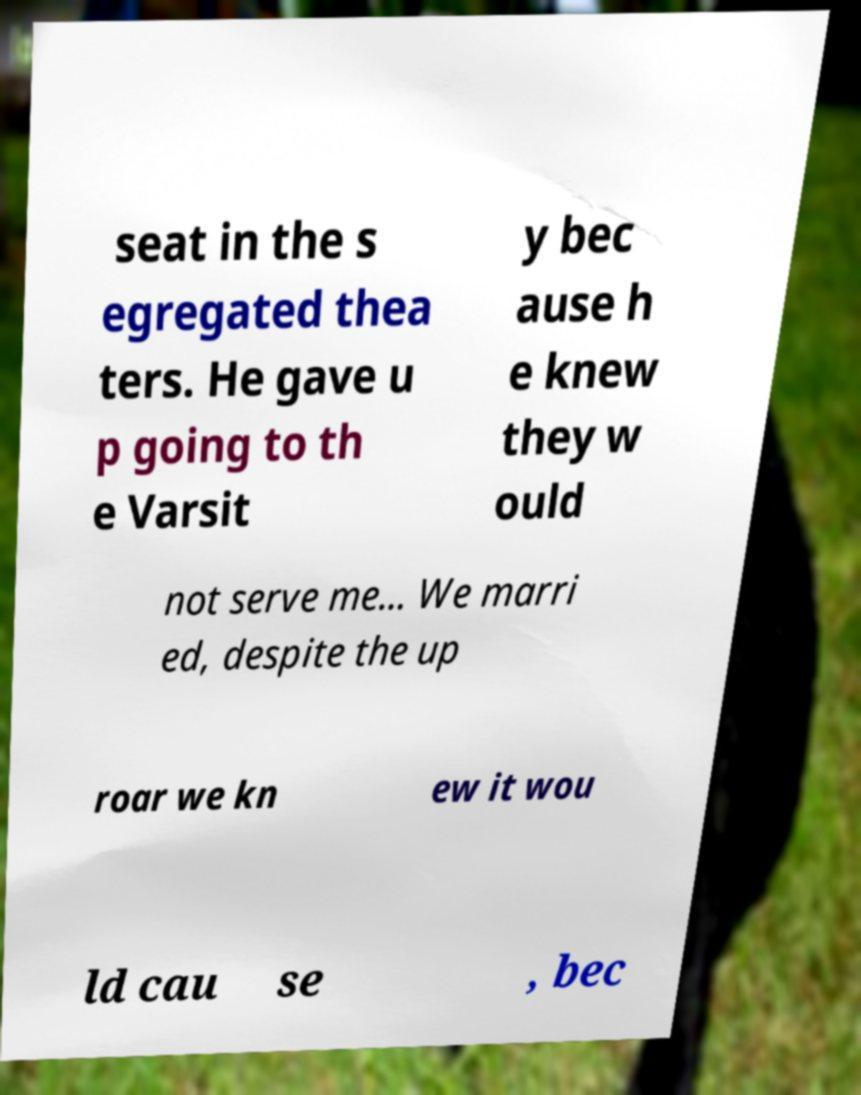I need the written content from this picture converted into text. Can you do that? seat in the s egregated thea ters. He gave u p going to th e Varsit y bec ause h e knew they w ould not serve me... We marri ed, despite the up roar we kn ew it wou ld cau se , bec 